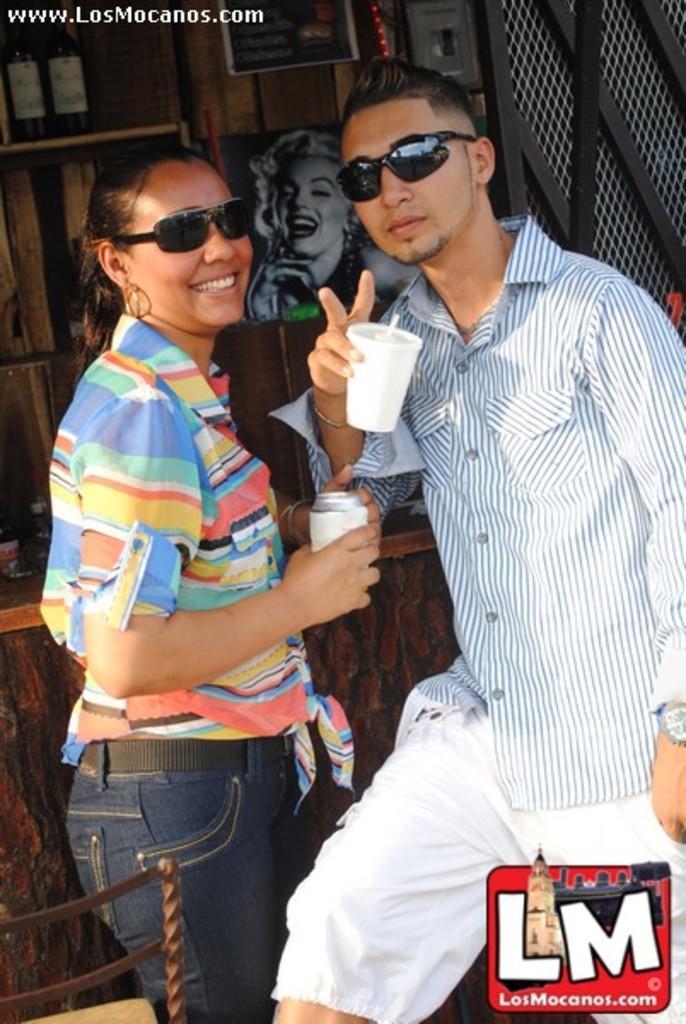In one or two sentences, can you explain what this image depicts? In this image I can see a person wearing white colored dress and black goggles is standing and holding a cup and a woman wearing blue, yellow and orange colored dress is standing and holding a white colored object in her hand. In the background I can see a table, few objects on the table, few bottles in the rack, a photo frame to the wall and few other objects. 